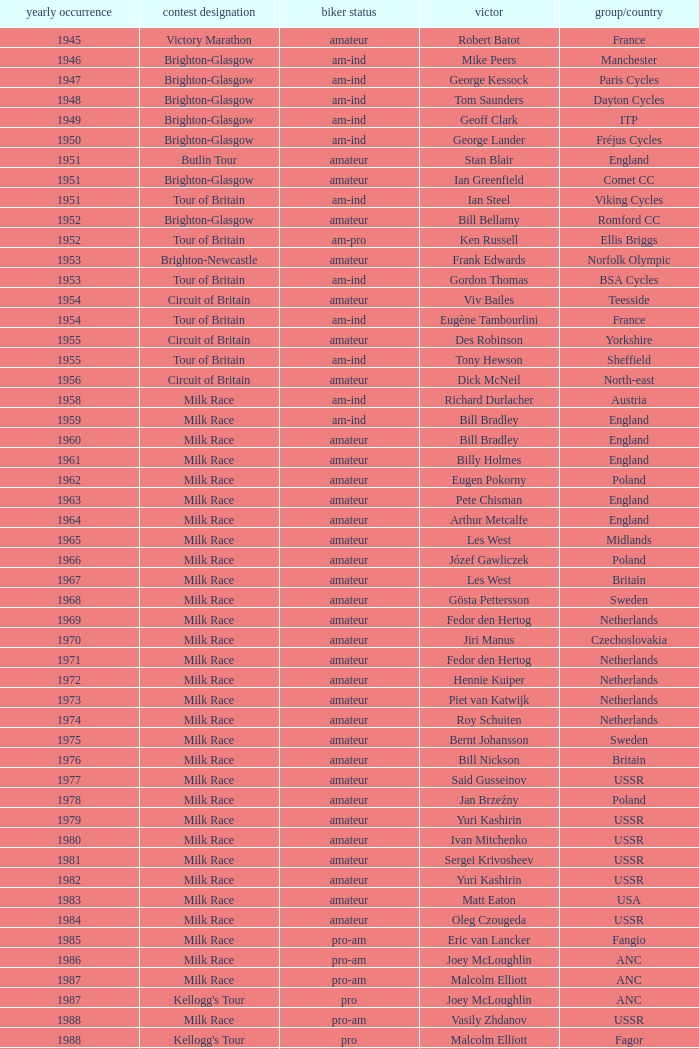What is the latest year when Phil Anderson won? 1993.0. 